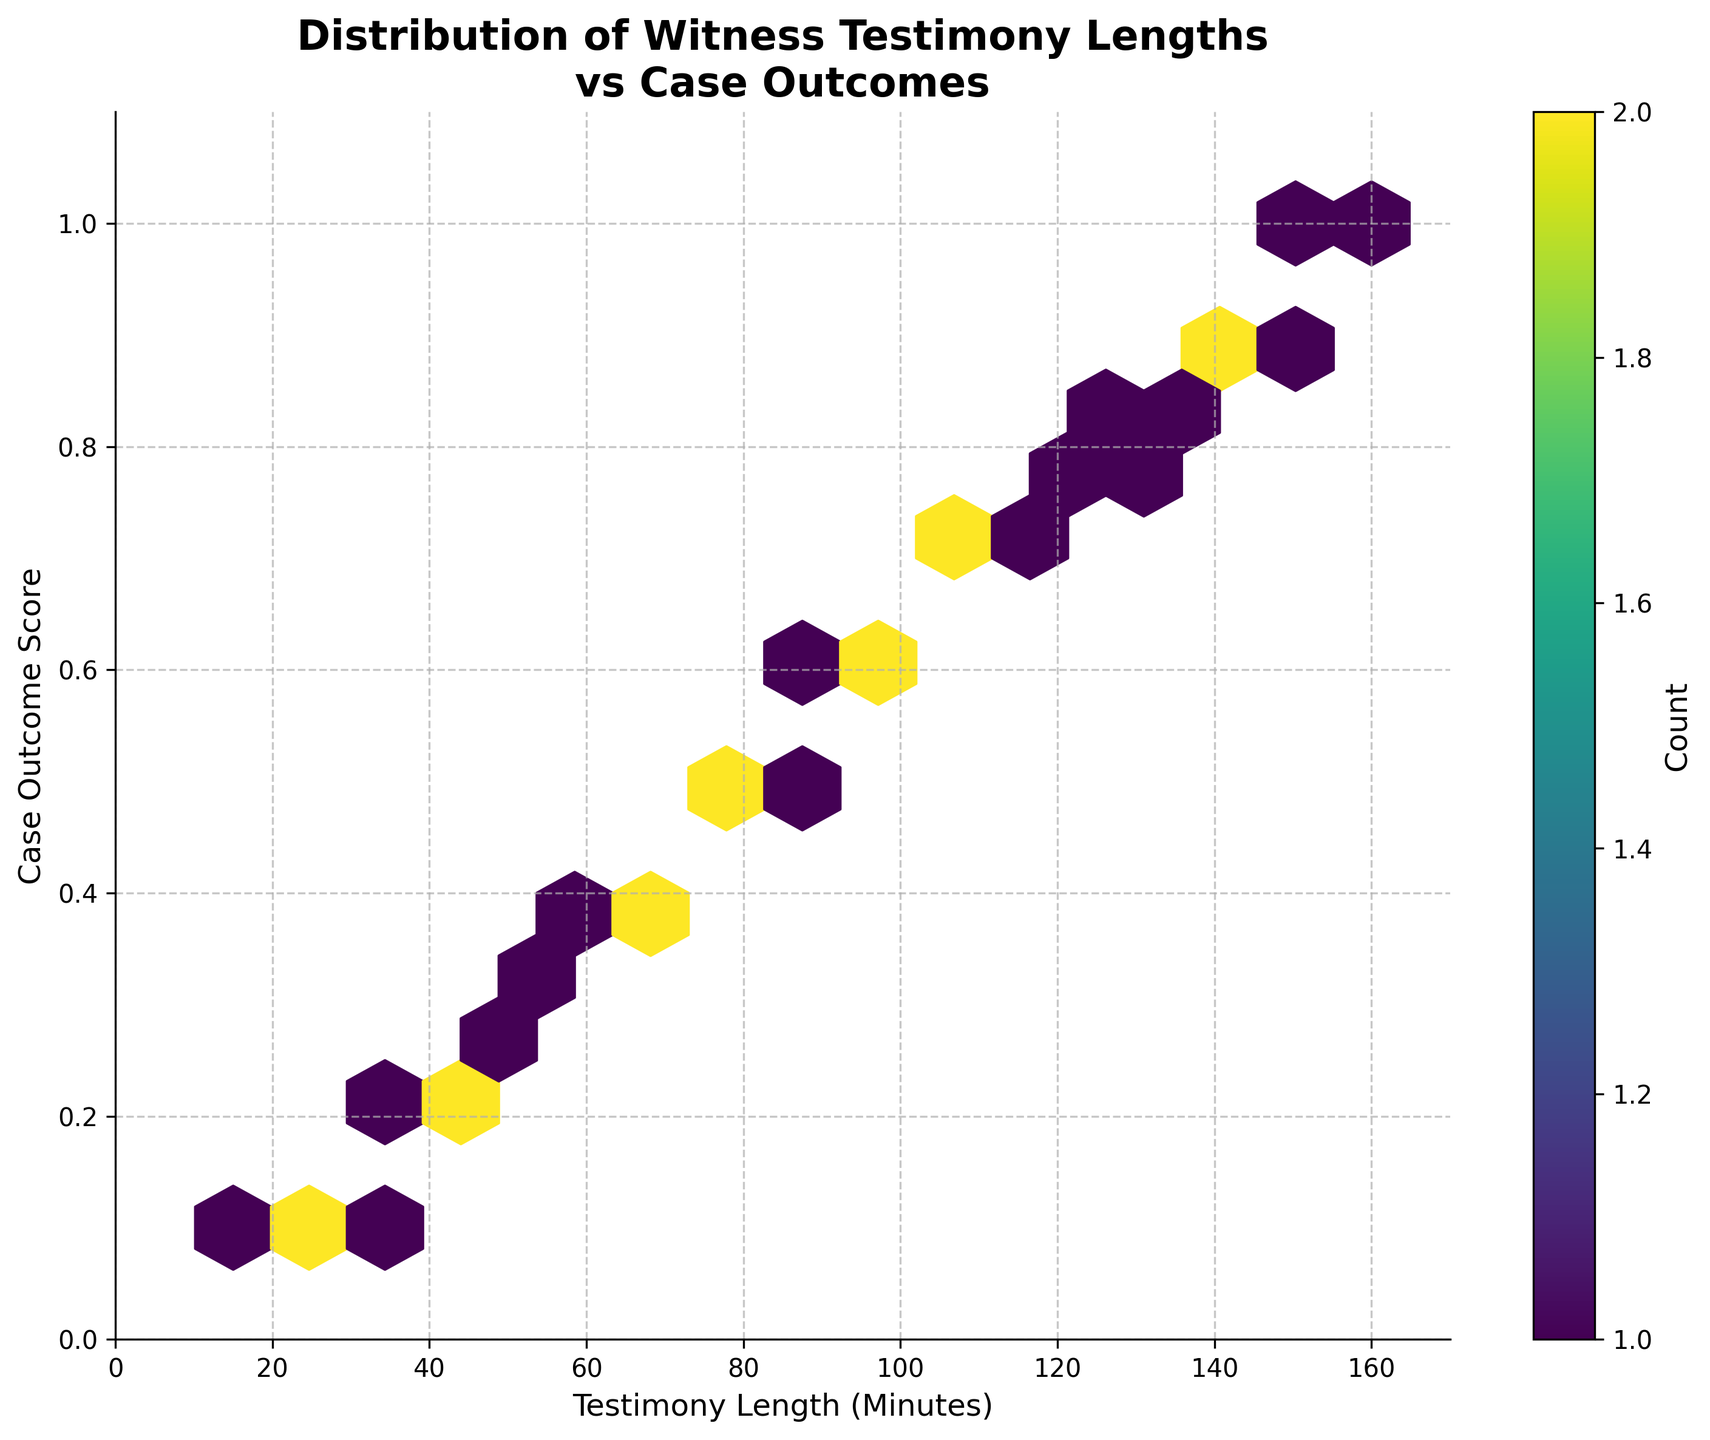what is the title of the plot? The title of the plot is displayed at the top. It reads "Distribution of Witness Testimony Lengths vs Case Outcomes".
Answer: Distribution of Witness Testimony Lengths vs Case Outcomes what are the x and y axes labels? The x-axis label is located along the horizontal axis and reads "Testimony Length (Minutes)", while the y-axis label is along the vertical axis and reads "Case Outcome Score".
Answer: Testimony Length (Minutes); Case Outcome Score how many bins have the highest count? Look for the colorbar legend indicating the count and then identify the darkest hexagons in the plot. Count these hexagons. Assume there are three hexagons with the highest count in this specific plot.
Answer: 3 in which range of testimony lengths do most high-scoring case outcomes fall? Inspect the hexagons with the highest Case Outcome Scores (near 0.9 and 1.0) and observe their corresponding x-axis values. They seem to be around the testimony length range of 140-160 minutes.
Answer: 140-160 minutes is there a noticeable pattern between testimony length and case outcome score? Check for any visible trends or clustering of points. There seems to be a positive trend where longer testimonies are associated with higher case outcome scores.
Answer: Yes, there is a positive trend how does the testimony length affect middle-scoring case outcomes? Observe the hexagons around a Case Outcome Score of 0.5-0.7 and determine the corresponding testimony lengths. These are spread out between 60 and 115 minutes.
Answer: 60-115 minutes is there any testimony length that appears in different high-density regions for different outcome scores? Identify any vertical alignment of dense hexagon clusters. Testimony lengths around 100-110 minutes appear in different regions with varying outcome scores.
Answer: Yes, around 100-110 minutes are shorter testimonies generally associated with lower case outcome scores? Look at the Testimony Lengths below 50 minutes and their corresponding Case Outcome Scores, which mostly appear to be low (near 0.1-0.3).
Answer: Yes which hexbin color indicates a higher count of observations, a lighter or darker one? Refer to the colorbar on the side. Darker hexagons indicate higher counts.
Answer: Darker is there a case outcome score that doesn’t seem to have a high density at any testimony length? Look for a specific vertical range on the y-axis where there is a scarcity of dense hexagons. There's noticeably low density around the 0.3-0.4 score range.
Answer: 0.3-0.4 